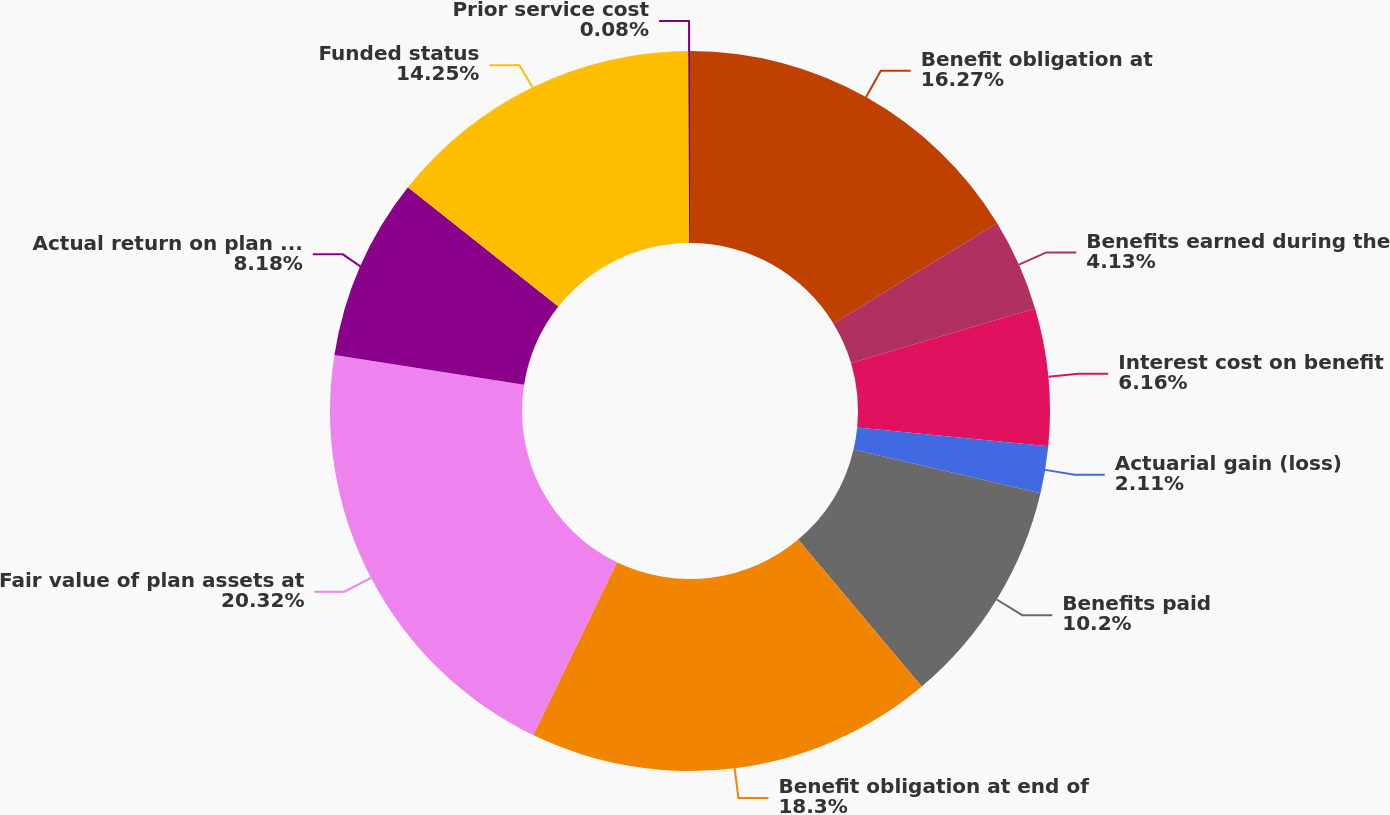<chart> <loc_0><loc_0><loc_500><loc_500><pie_chart><fcel>Benefit obligation at<fcel>Benefits earned during the<fcel>Interest cost on benefit<fcel>Actuarial gain (loss)<fcel>Benefits paid<fcel>Benefit obligation at end of<fcel>Fair value of plan assets at<fcel>Actual return on plan assets<fcel>Funded status<fcel>Prior service cost<nl><fcel>16.27%<fcel>4.13%<fcel>6.16%<fcel>2.11%<fcel>10.2%<fcel>18.3%<fcel>20.32%<fcel>8.18%<fcel>14.25%<fcel>0.08%<nl></chart> 